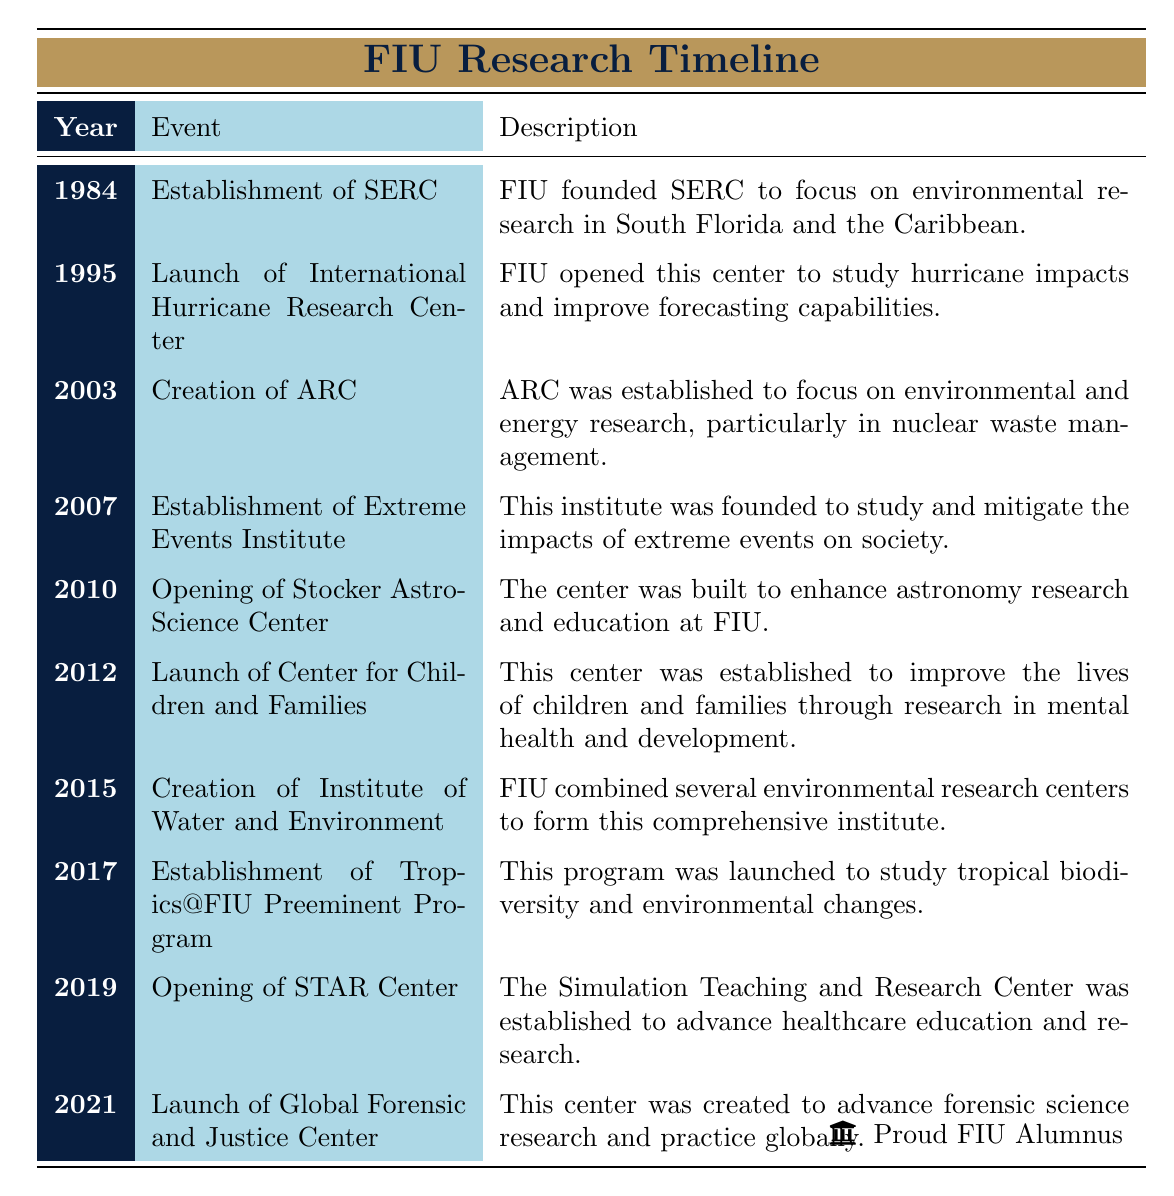What year was the Southeast Environmental Research Center established? The table indicates that the Southeast Environmental Research Center (SERC) was established in the year 1984.
Answer: 1984 Which center was launched in 2012? According to the table, the Center for Children and Families was launched in 2012.
Answer: Center for Children and Families How many centers were established before 2010? By examining the table, the events listed before 2010 are: 1984 (SERC), 1995 (International Hurricane Research Center), 2003 (ARC), and 2007 (Extreme Events Institute). This totals four centers.
Answer: 4 Was the Stocker AstroScience Center opened after the establishment of the Tropics@FIU Preeminent Program? The Stocker AstroScience Center was opened in 2010 and the Tropics@FIU Preeminent Program was established in 2017, meaning that the Stocker AstroScience Center was opened before the Tropics@FIU Preeminent Program.
Answer: No What is the difference in years between the establishment of the Global Forensic and Justice Center and the opening of the STAR Center? The Global Forensic and Justice Center was launched in 2021 and the STAR Center was opened in 2019. The difference, calculated as 2021 - 2019, is 2 years.
Answer: 2 